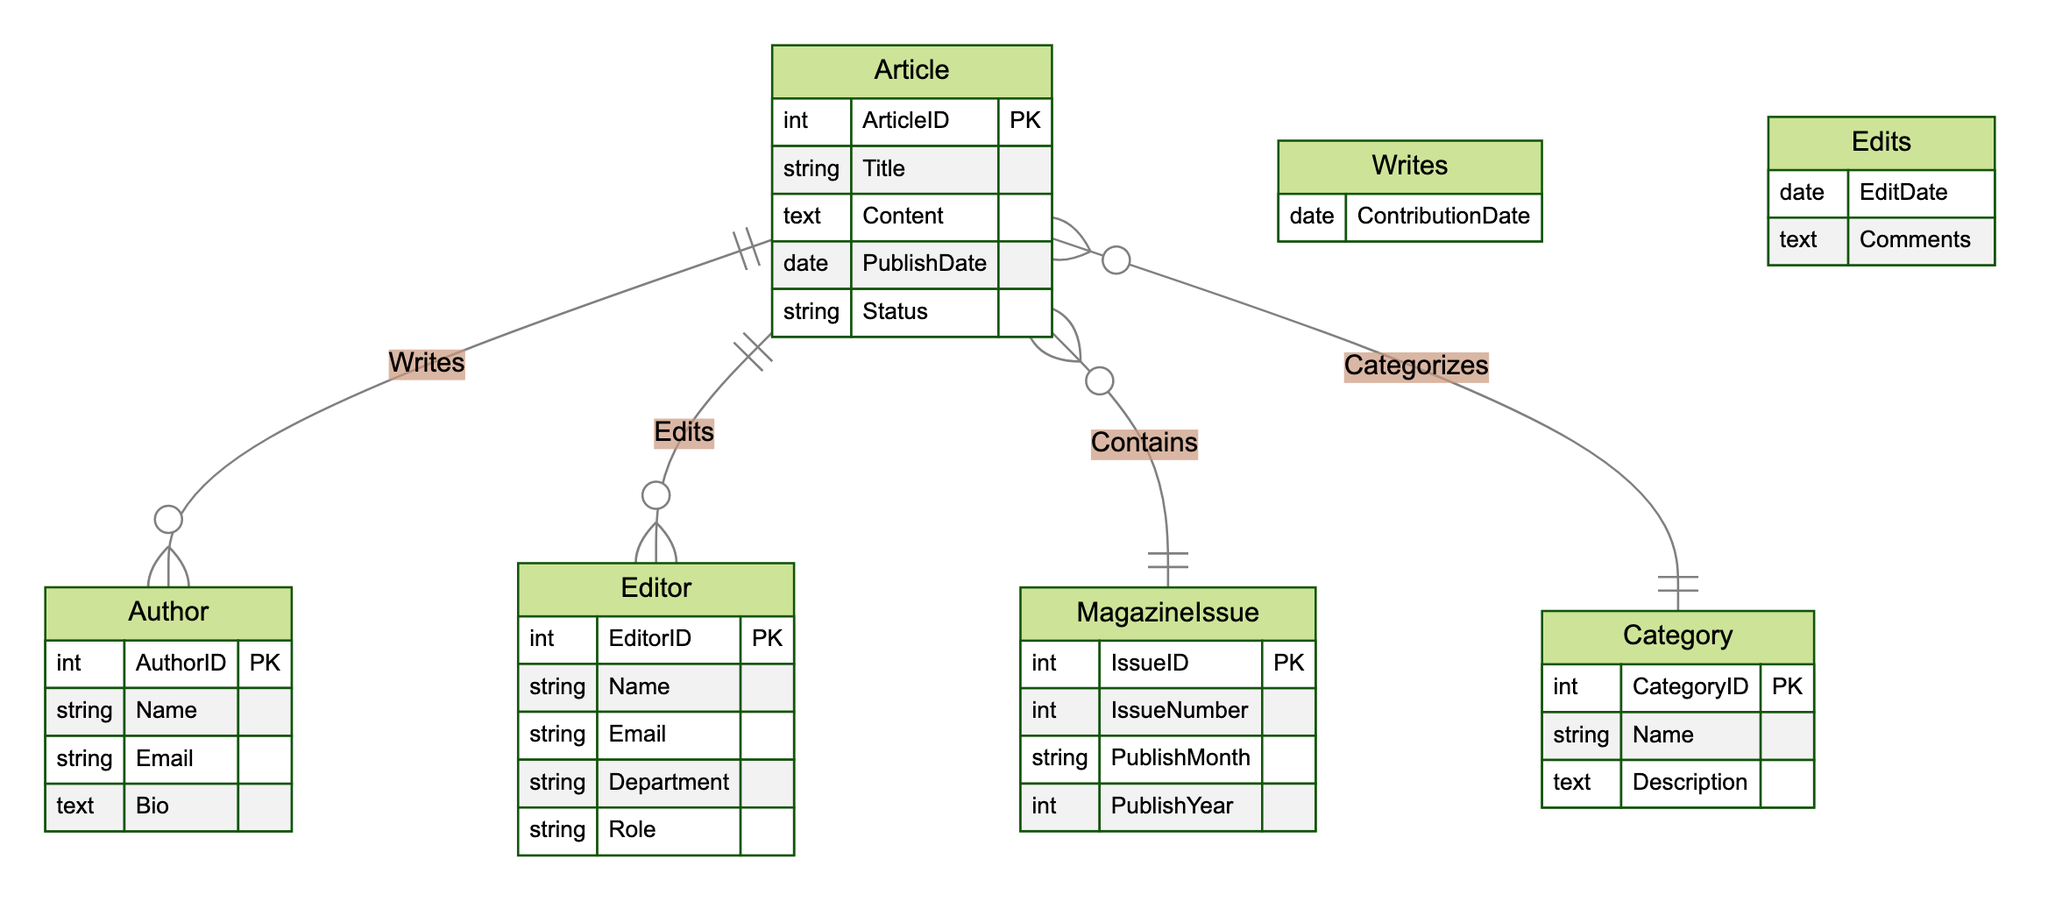What is the primary key of the Article entity? The primary key attribute for the Article entity is specified as ArticleID, which uniquely identifies each article within the database.
Answer: ArticleID How many entities are present in the diagram? The diagram contains five entities: Article, Author, Editor, MagazineIssue, and Category. By counting them, we find that there are five distinct entities represented.
Answer: Five What is the relationship between Article and Author? The relationship defined between Article and Author is labeled as "Writes". This indicates that authors contribute to the articles they write.
Answer: Writes What attribute is included in the Edits relationship? The Edits relationship includes two attributes: EditDate and Comments. This indicates when the article was edited and any additional comments made by the editor.
Answer: EditDate, Comments How many relationships are represented in the diagram? There are four defined relationships: Writes, Edits, Contains, and Categorizes. By counting these relationships, we determine that there are four total in the diagram.
Answer: Four Which entity is directly connected to MagazineIssue? The Article entity is the only entity connected directly to MagazineIssue through the Contains relationship, indicating which articles are part of specific magazine issues.
Answer: Article What is the attribute that connects an author to an article? The attribute that connects an author to an article is ContributionDate, which indicates when the author contributed to the article they wrote.
Answer: ContributionDate Which entity has "Bio" as one of its attributes? The Author entity has "Bio" as one of its attributes, providing background information about the author.
Answer: Author What does the Contains relationship represent? The Contains relationship represents the association between a MagazineIssue and the articles that are included in that issue, linking specific articles to particular magazine issues.
Answer: Association between MagazineIssue and Article Which entity's attributes include "Department"? The Editor entity includes the attribute "Department", indicating the specific department within the magazine in which the editor works.
Answer: Editor 